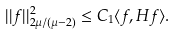Convert formula to latex. <formula><loc_0><loc_0><loc_500><loc_500>| | f | | ^ { 2 } _ { 2 \mu / ( \mu - 2 ) } \leq C _ { 1 } \langle f , H f \rangle .</formula> 